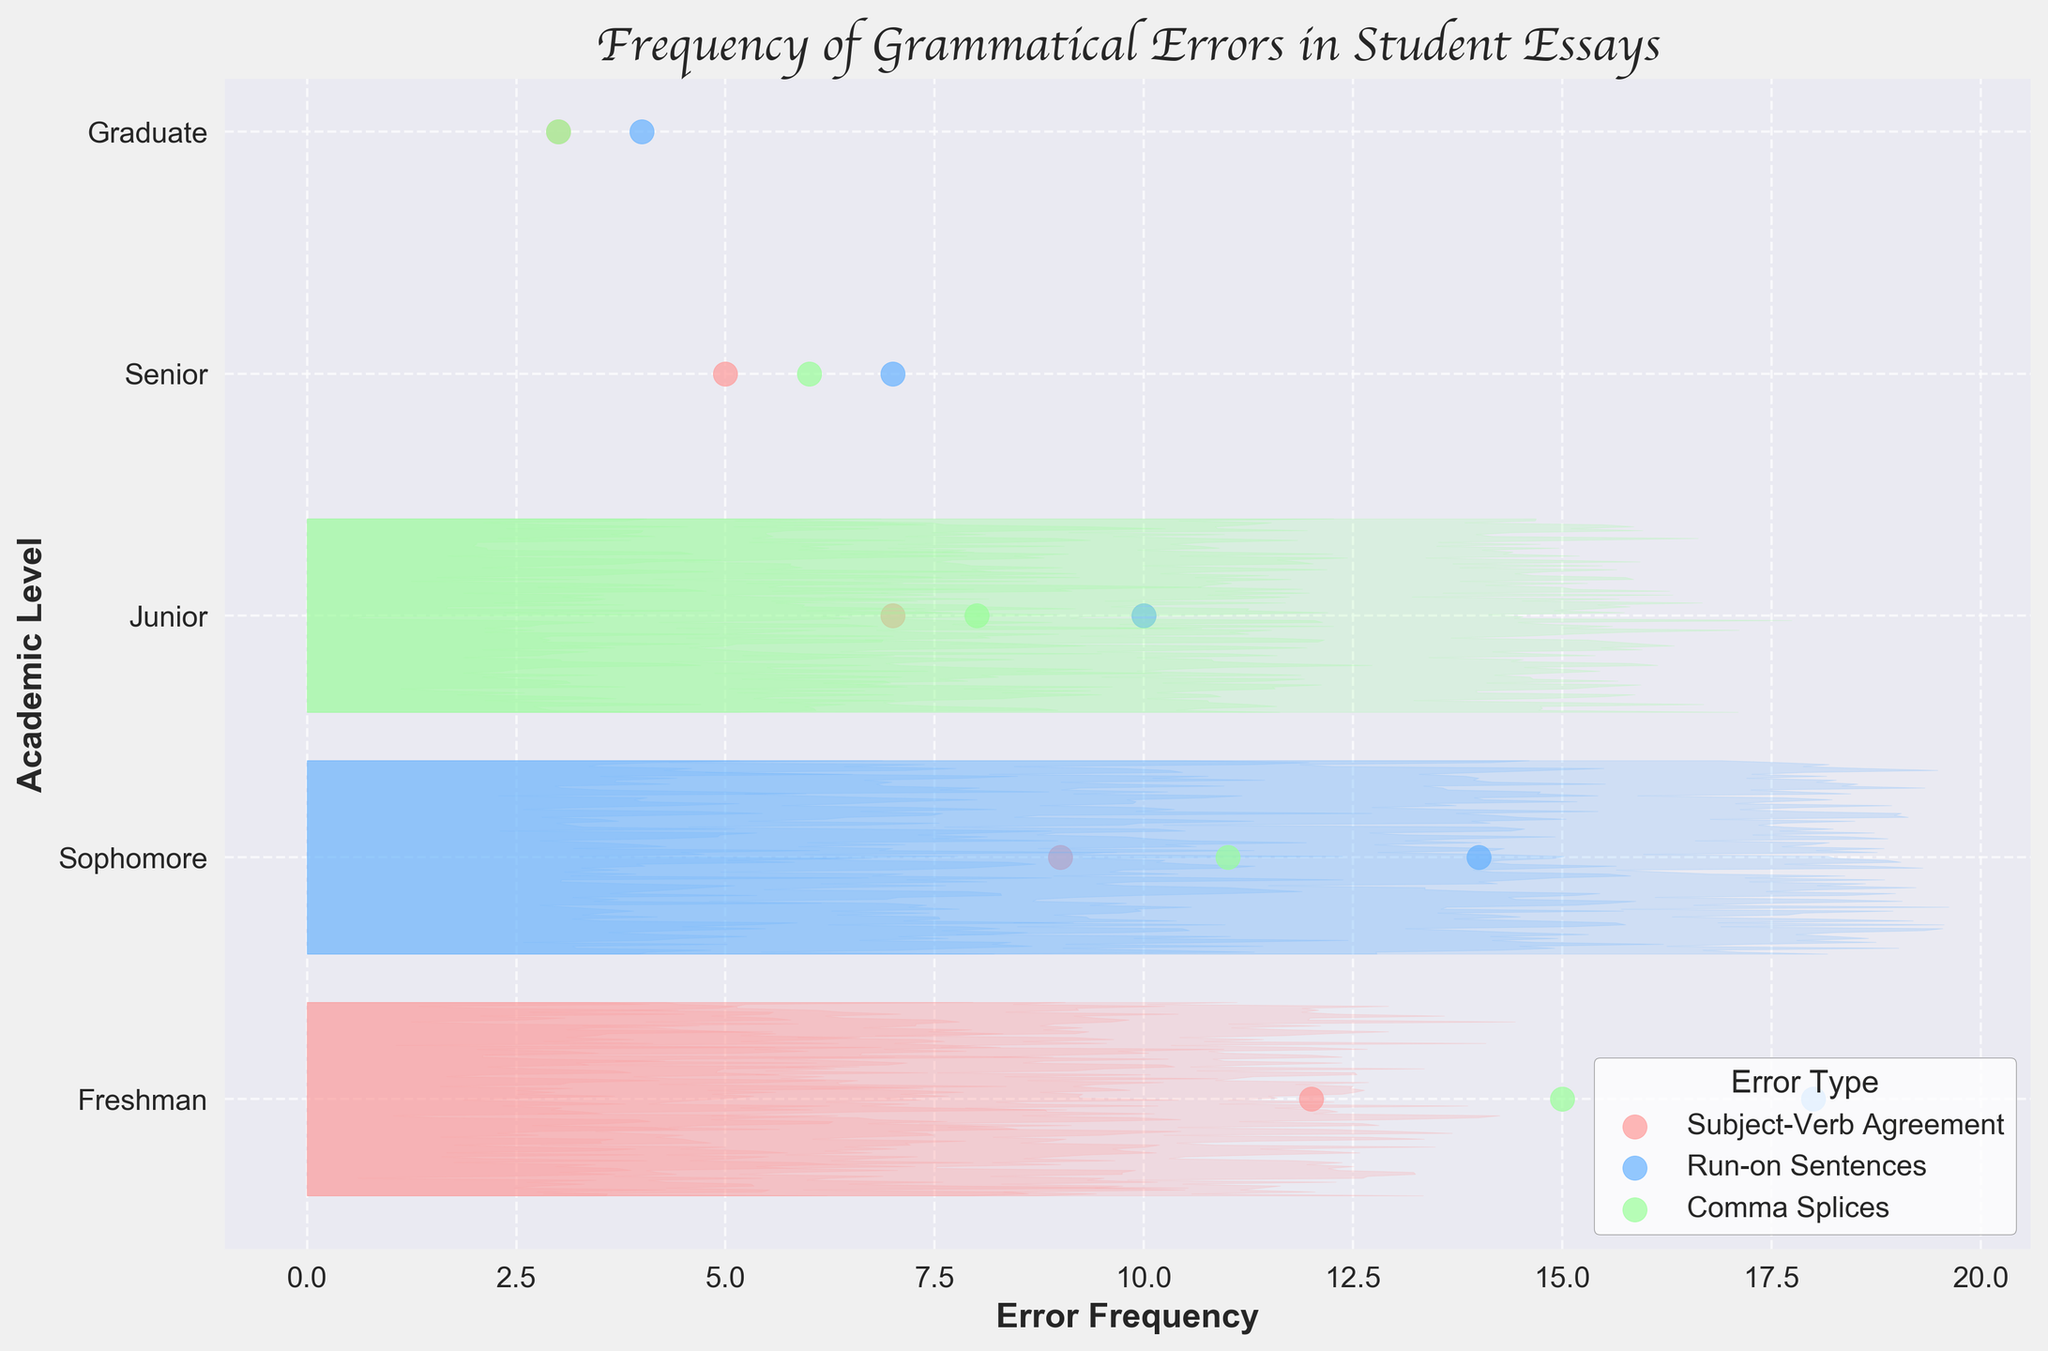What is the title of the plot? The title is located at the top of the plot and provides a summary of what the figure is about. In this case, the title is "Frequency of Grammatical Errors in Student Essays."
Answer: Frequency of Grammatical Errors in Student Essays What error type is represented by the blue dots? By referring to the legend in the plot, we can associate the blue dots with their corresponding label. The blue dots are labeled as "Run-on Sentences."
Answer: Run-on Sentences How many error types are compared in this plot? The legend shows three different labels, each corresponding to a different color. Thus, there are three error types compared in the plot.
Answer: Three Which academic level exhibits the highest frequency of Run-on Sentences? By looking at the blue dots and their frequencies, we can see that Freshman students have an error frequency of 18 for Run-on Sentences, which is the highest among all levels.
Answer: Freshman Which academic level has the lowest frequency of Subject-Verb Agreement errors? The lowest frequency for Subject-Verb Agreement errors can be found by looking at the positions of the red dots, and we can observe that Graduate level has the lowest frequency of 3.
Answer: Graduate What is the average frequency of Comma Splices across all academic levels? Sum the frequencies of Comma Splices for all levels (15+11+8+6+3) which equals 43, and then divide by the number of levels (5). Thus, the average is 43/5.
Answer: 8.6 By how much do the Subject-Verb Agreement errors decrease from Freshman to Senior level? The frequency of Subject-Verb Agreement errors is 12 for Freshman and 5 for Senior. The decrease is computed by subtracting the Senior value from the Freshman value: 12 - 5.
Answer: 7 Do Juniors or Sophomores have a higher frequency of Comma Splices? By comparing the green dots for Juniors and Sophomores, it is clear that Sophomores (11) have a higher frequency than Juniors (8).
Answer: Sophomores Are error frequencies for Run-on Sentences higher or lower for Seniors compared to Freshmen? By focusing on the blue dots for both academic levels, we see that Freshmen have a frequency of 18 and Seniors have a frequency of 7. Therefore, the frequency is lower for Seniors.
Answer: Lower Is there a trend in error frequency as students progress from Freshman to Graduate level? To identify a trend, we observe the general movement of points across academic levels. For all three error types, frequencies generally decrease as the academic level progresses from Freshman to Graduate, indicating a downward trend.
Answer: Downward trend 